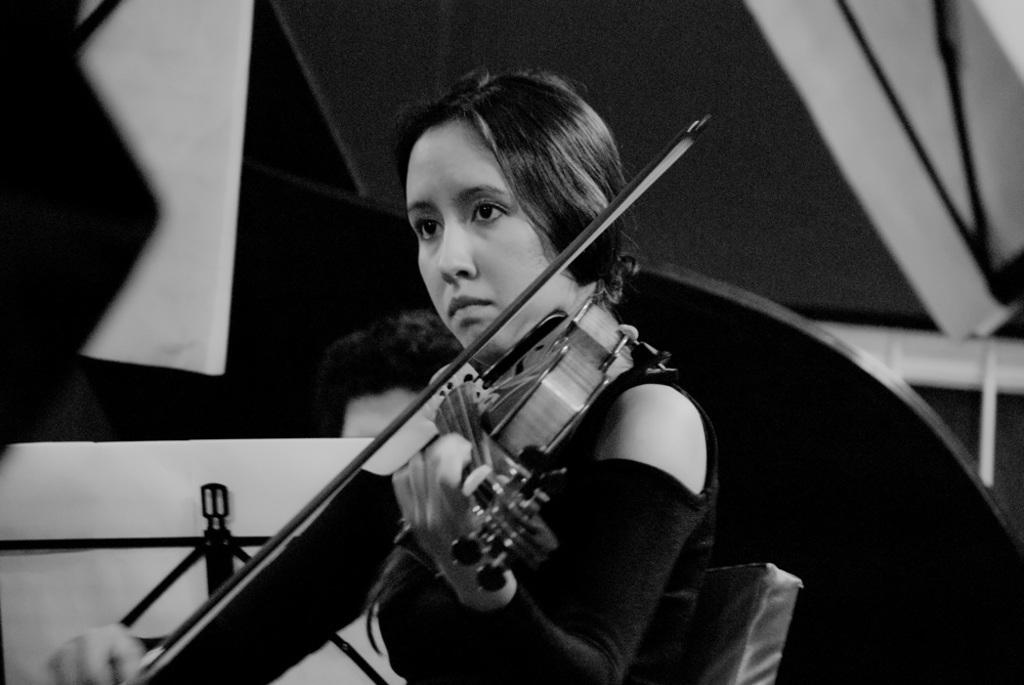Who is the main subject in the image? There is a woman in the image. Where is the woman located in the image? The woman is sitting in the center of the image. What is the woman doing in the image? The woman is playing a violin. What can be seen on the left side of the image? There is a stand on the left side of the image. What is visible in the background of the image? There are many strands in the background of the image. What type of table is visible in the image? There is no table present in the image. Can you hear the sound of thunder in the image? There is no sound or indication of thunder in the image. 